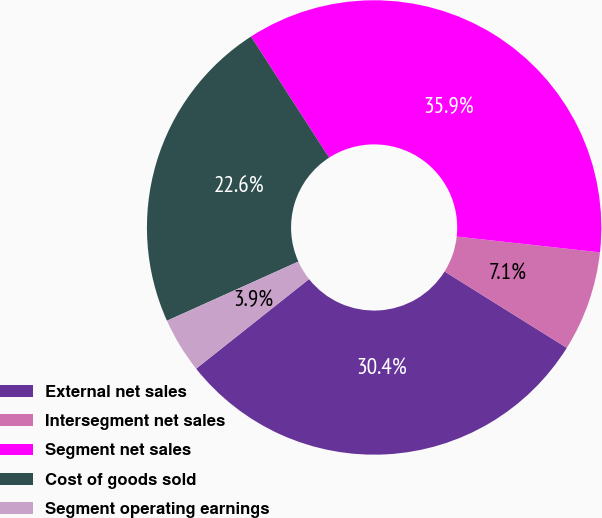Convert chart. <chart><loc_0><loc_0><loc_500><loc_500><pie_chart><fcel>External net sales<fcel>Intersegment net sales<fcel>Segment net sales<fcel>Cost of goods sold<fcel>Segment operating earnings<nl><fcel>30.44%<fcel>7.14%<fcel>35.86%<fcel>22.62%<fcel>3.94%<nl></chart> 